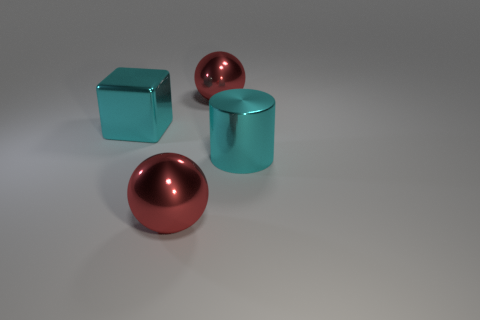Add 3 small green rubber cylinders. How many objects exist? 7 Subtract all cubes. How many objects are left? 3 Add 4 metal objects. How many metal objects are left? 8 Add 3 cyan objects. How many cyan objects exist? 5 Subtract 1 cyan cylinders. How many objects are left? 3 Subtract all large metallic objects. Subtract all big gray metal cylinders. How many objects are left? 0 